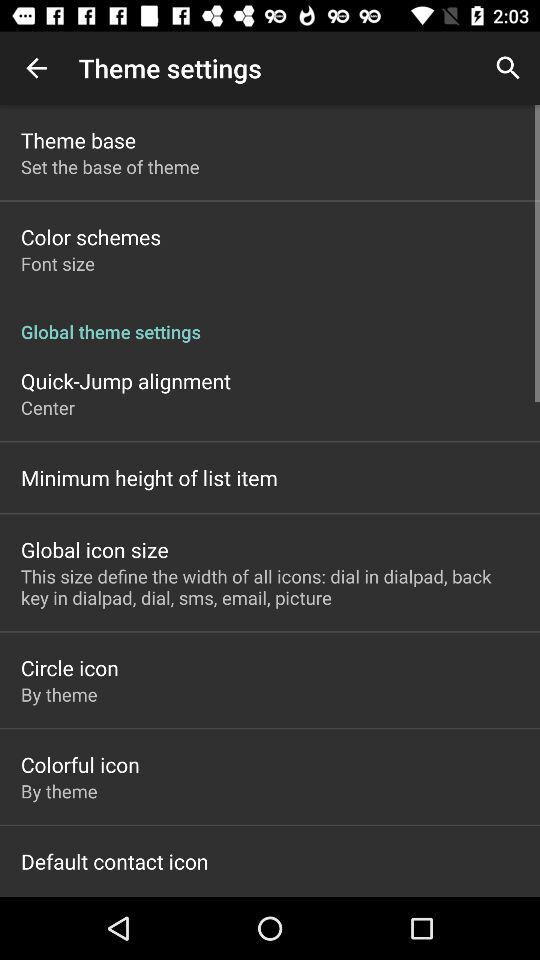What is the global icon size? The global icon size defines the width of all icons: dial in dialpad, back key in dialpad, dial, sms, email and picture. 